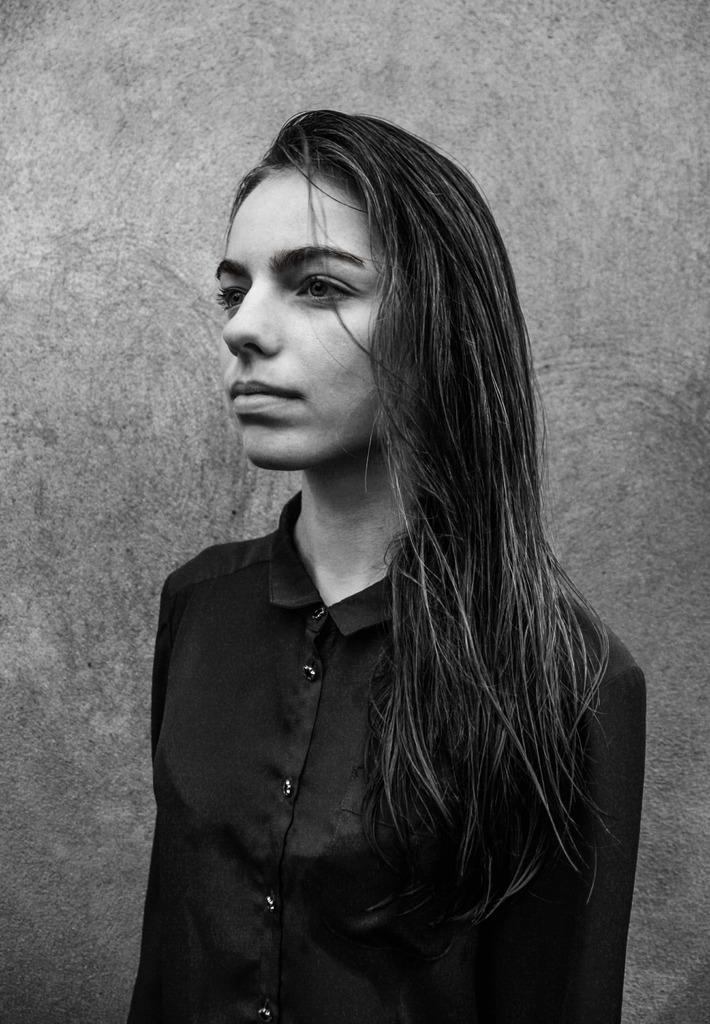Who is the main subject in the image? There is a girl in the image. Where is the girl located in relation to the image? The girl is standing in the foreground area. What can be seen in the background of the image? There is a wall in the background of the image. What type of cattle can be seen grazing near the girl in the image? There are no cattle present in the image; it only features a girl standing in the foreground and a wall in the background. 